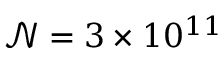Convert formula to latex. <formula><loc_0><loc_0><loc_500><loc_500>\mathcal { N } = 3 \times 1 0 ^ { 1 1 }</formula> 